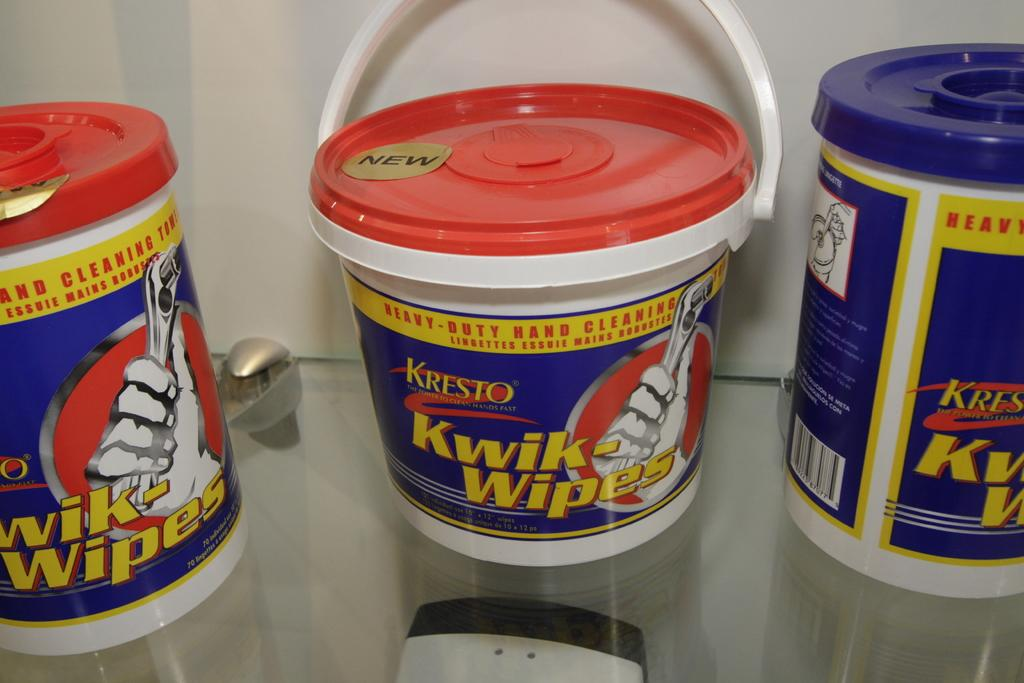<image>
Create a compact narrative representing the image presented. a few buckets of quick wipes near each other 